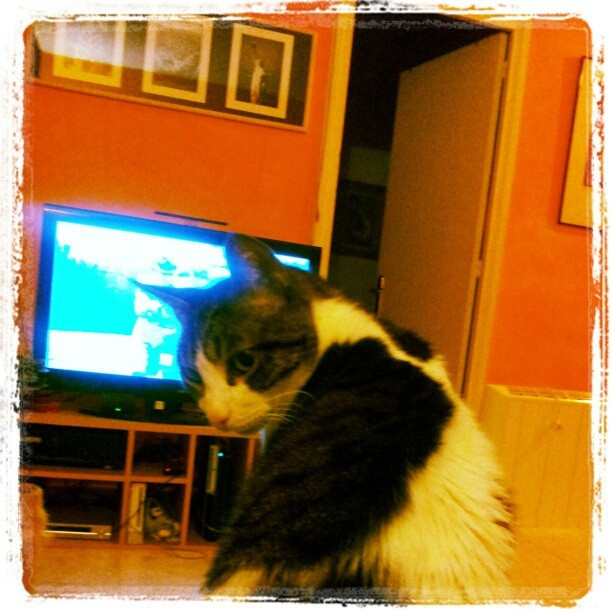Describe the objects in this image and their specific colors. I can see cat in white, black, orange, and gold tones and tv in white, cyan, lightblue, and blue tones in this image. 